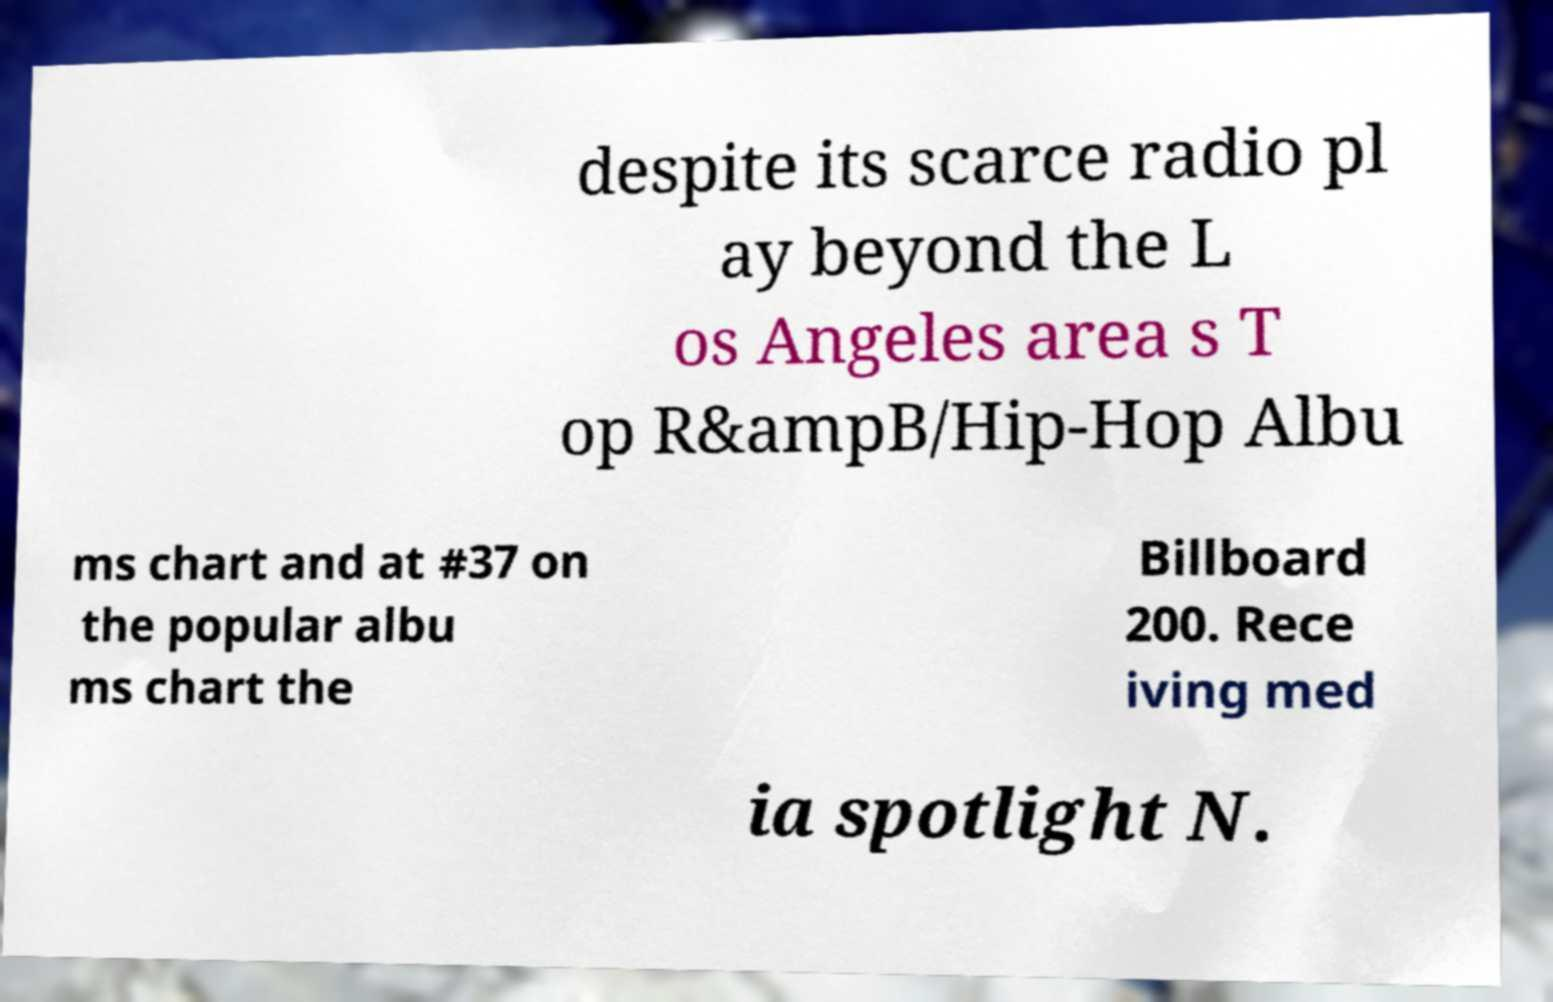What messages or text are displayed in this image? I need them in a readable, typed format. despite its scarce radio pl ay beyond the L os Angeles area s T op R&ampB/Hip-Hop Albu ms chart and at #37 on the popular albu ms chart the Billboard 200. Rece iving med ia spotlight N. 